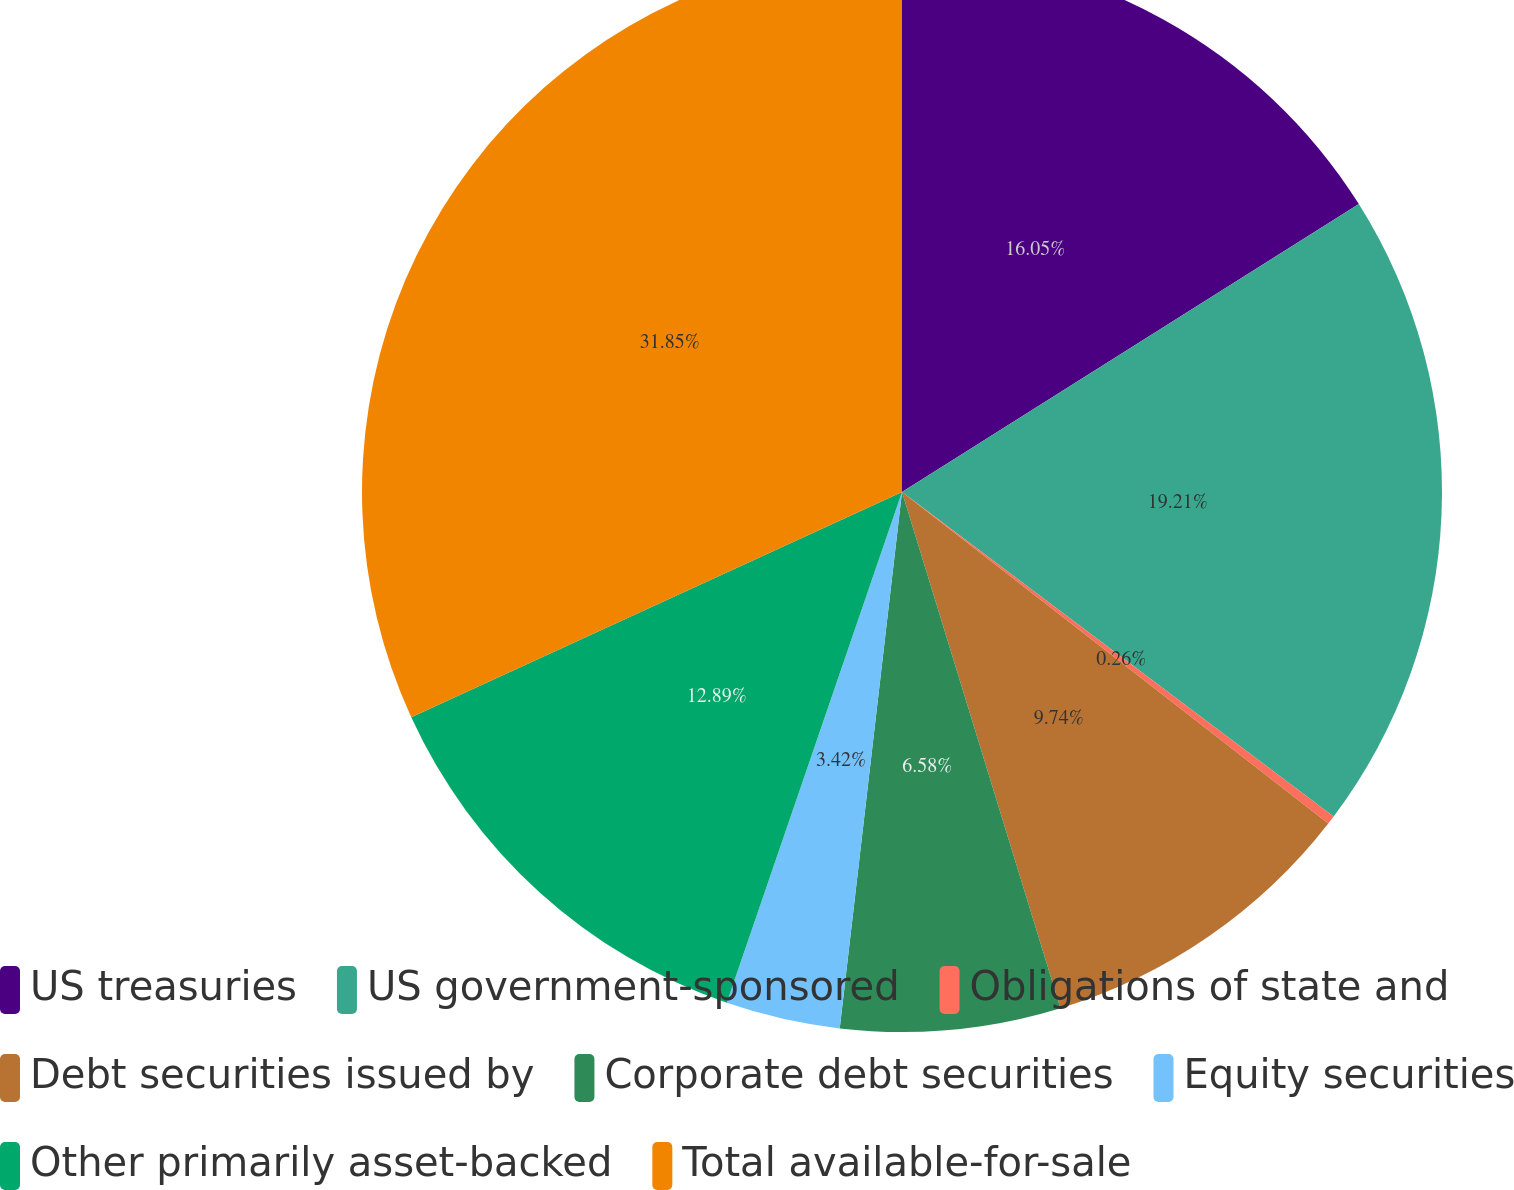Convert chart to OTSL. <chart><loc_0><loc_0><loc_500><loc_500><pie_chart><fcel>US treasuries<fcel>US government-sponsored<fcel>Obligations of state and<fcel>Debt securities issued by<fcel>Corporate debt securities<fcel>Equity securities<fcel>Other primarily asset-backed<fcel>Total available-for-sale<nl><fcel>16.05%<fcel>19.21%<fcel>0.26%<fcel>9.74%<fcel>6.58%<fcel>3.42%<fcel>12.89%<fcel>31.85%<nl></chart> 